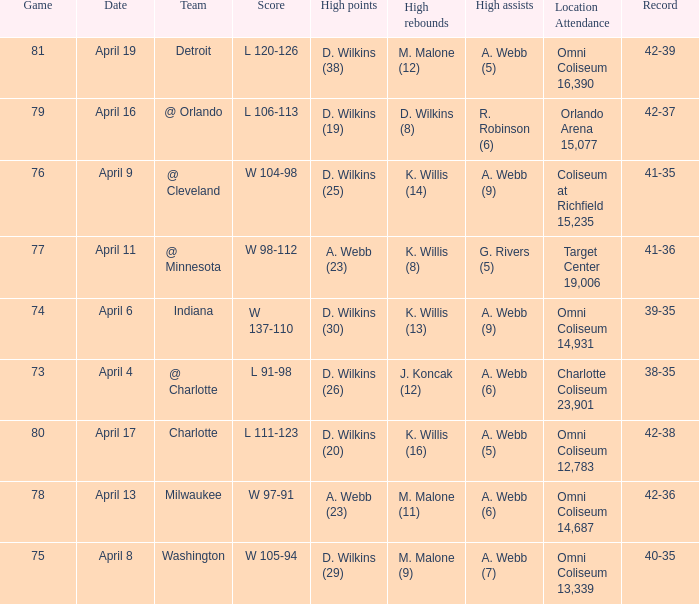Where was the location and attendance when they played milwaukee? Omni Coliseum 14,687. 